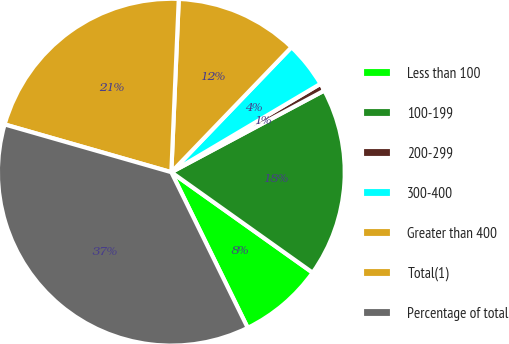Convert chart to OTSL. <chart><loc_0><loc_0><loc_500><loc_500><pie_chart><fcel>Less than 100<fcel>100-199<fcel>200-299<fcel>300-400<fcel>Greater than 400<fcel>Total(1)<fcel>Percentage of total<nl><fcel>7.9%<fcel>17.64%<fcel>0.71%<fcel>4.3%<fcel>11.5%<fcel>21.24%<fcel>36.7%<nl></chart> 